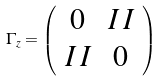<formula> <loc_0><loc_0><loc_500><loc_500>\Gamma _ { z } = \left ( \begin{array} { c c } 0 & I \, I \\ I \, I & 0 \end{array} \right ) \</formula> 